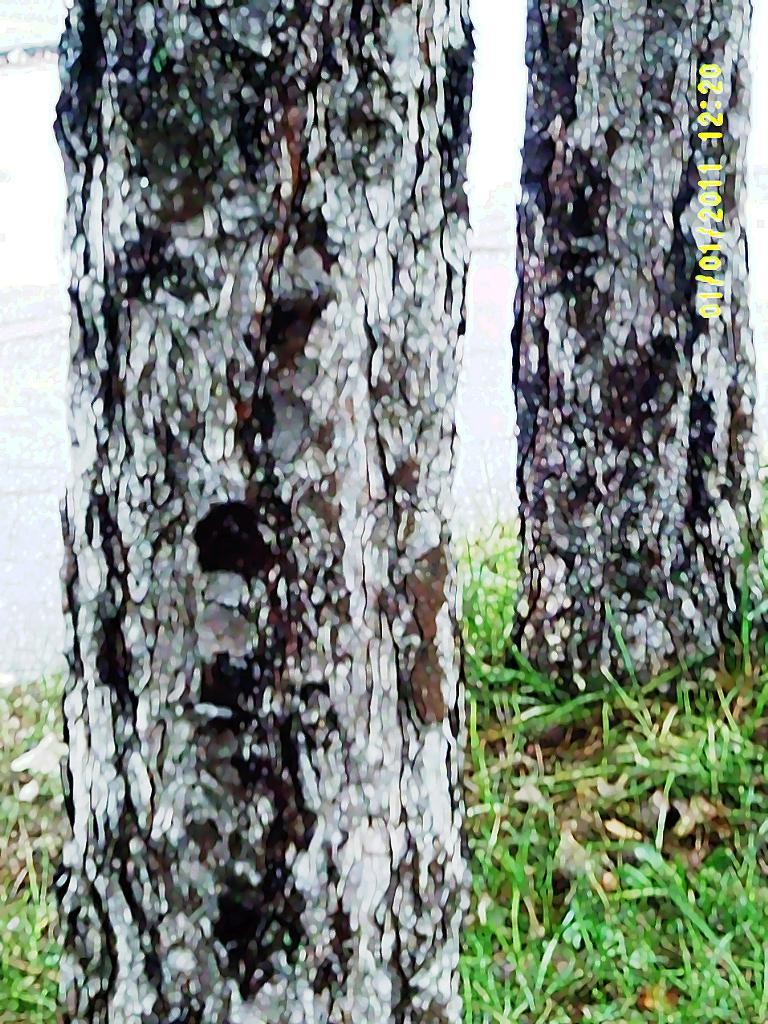How many trees are in the image? There are two trees in the image. What type of vegetation is on the ground in the image? There is grass on the ground in the image. What can be seen besides the trees and grass in the image? There is water visible in the image. Where is the watermark located in the image? The watermark is located in the right top corner of the image. What type of instrument is being played by the cloth in the image? There is no cloth or instrument present in the image. 